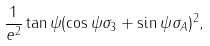Convert formula to latex. <formula><loc_0><loc_0><loc_500><loc_500>\frac { 1 } { e ^ { 2 } } \tan \psi ( \cos \psi \sigma _ { 3 } + \sin \psi \sigma _ { A } ) ^ { 2 } ,</formula> 